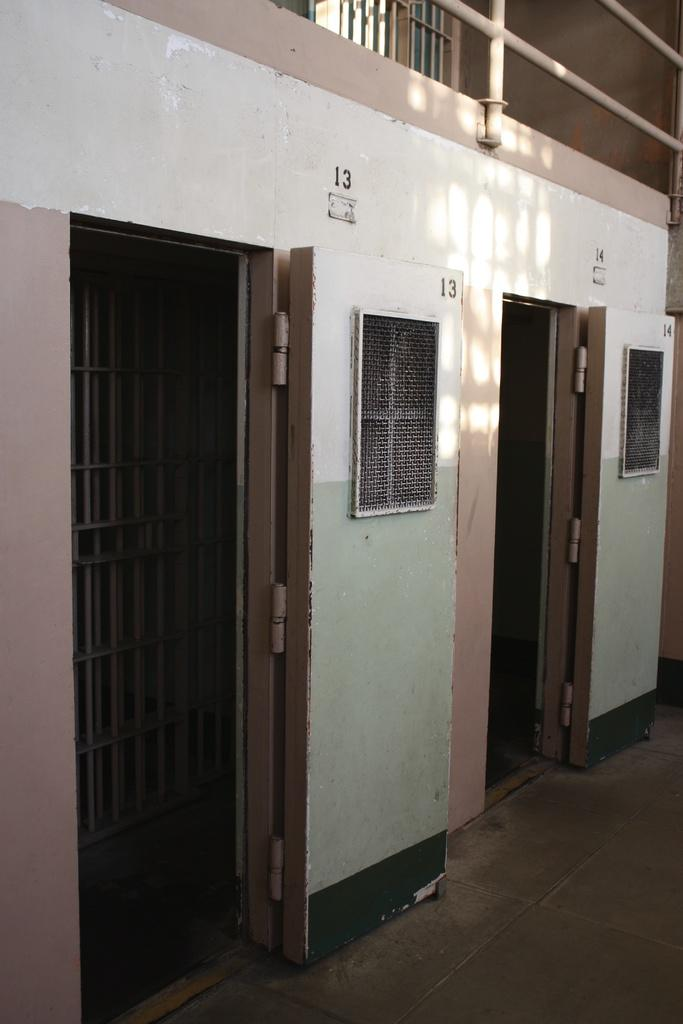What type of structures can be seen in the image? There are doors, a wall, and a fence in the image. Can you describe the doors in the image? The doors are part of the structures visible in the image. What else is present on the wall in the image? The provided facts do not mention any additional details about the wall. What type of honey is being used to paint the fence in the image? There is no honey present in the image, and the fence is not being painted. 